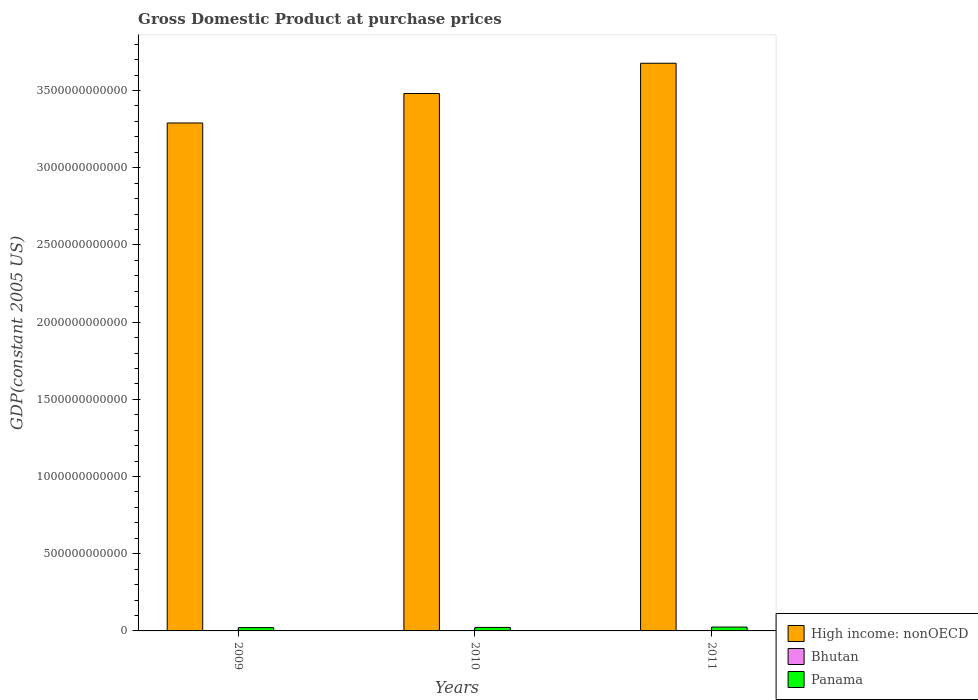Are the number of bars per tick equal to the number of legend labels?
Ensure brevity in your answer.  Yes. How many bars are there on the 1st tick from the left?
Give a very brief answer. 3. How many bars are there on the 1st tick from the right?
Your answer should be very brief. 3. What is the label of the 1st group of bars from the left?
Offer a terse response. 2009. In how many cases, is the number of bars for a given year not equal to the number of legend labels?
Offer a terse response. 0. What is the GDP at purchase prices in High income: nonOECD in 2011?
Your answer should be compact. 3.68e+12. Across all years, what is the maximum GDP at purchase prices in Panama?
Offer a terse response. 2.50e+1. Across all years, what is the minimum GDP at purchase prices in Bhutan?
Ensure brevity in your answer.  1.15e+09. In which year was the GDP at purchase prices in Panama maximum?
Provide a short and direct response. 2011. What is the total GDP at purchase prices in Bhutan in the graph?
Offer a terse response. 3.83e+09. What is the difference between the GDP at purchase prices in Panama in 2010 and that in 2011?
Your response must be concise. -2.43e+09. What is the difference between the GDP at purchase prices in Panama in 2011 and the GDP at purchase prices in High income: nonOECD in 2009?
Give a very brief answer. -3.26e+12. What is the average GDP at purchase prices in Panama per year?
Your answer should be very brief. 2.30e+1. In the year 2009, what is the difference between the GDP at purchase prices in Panama and GDP at purchase prices in Bhutan?
Provide a succinct answer. 2.02e+1. What is the ratio of the GDP at purchase prices in Panama in 2010 to that in 2011?
Your answer should be compact. 0.9. Is the GDP at purchase prices in High income: nonOECD in 2009 less than that in 2010?
Offer a very short reply. Yes. Is the difference between the GDP at purchase prices in Panama in 2009 and 2010 greater than the difference between the GDP at purchase prices in Bhutan in 2009 and 2010?
Offer a terse response. No. What is the difference between the highest and the second highest GDP at purchase prices in High income: nonOECD?
Make the answer very short. 1.96e+11. What is the difference between the highest and the lowest GDP at purchase prices in High income: nonOECD?
Your answer should be compact. 3.87e+11. In how many years, is the GDP at purchase prices in Bhutan greater than the average GDP at purchase prices in Bhutan taken over all years?
Your answer should be compact. 2. Is the sum of the GDP at purchase prices in Bhutan in 2009 and 2011 greater than the maximum GDP at purchase prices in High income: nonOECD across all years?
Ensure brevity in your answer.  No. What does the 1st bar from the left in 2009 represents?
Keep it short and to the point. High income: nonOECD. What does the 3rd bar from the right in 2011 represents?
Make the answer very short. High income: nonOECD. Is it the case that in every year, the sum of the GDP at purchase prices in Panama and GDP at purchase prices in High income: nonOECD is greater than the GDP at purchase prices in Bhutan?
Provide a short and direct response. Yes. How many bars are there?
Your answer should be very brief. 9. Are all the bars in the graph horizontal?
Give a very brief answer. No. What is the difference between two consecutive major ticks on the Y-axis?
Ensure brevity in your answer.  5.00e+11. Does the graph contain any zero values?
Keep it short and to the point. No. Does the graph contain grids?
Offer a very short reply. No. Where does the legend appear in the graph?
Your answer should be very brief. Bottom right. How are the legend labels stacked?
Give a very brief answer. Vertical. What is the title of the graph?
Your response must be concise. Gross Domestic Product at purchase prices. Does "French Polynesia" appear as one of the legend labels in the graph?
Offer a very short reply. No. What is the label or title of the X-axis?
Give a very brief answer. Years. What is the label or title of the Y-axis?
Your response must be concise. GDP(constant 2005 US). What is the GDP(constant 2005 US) in High income: nonOECD in 2009?
Make the answer very short. 3.29e+12. What is the GDP(constant 2005 US) of Bhutan in 2009?
Provide a short and direct response. 1.15e+09. What is the GDP(constant 2005 US) in Panama in 2009?
Make the answer very short. 2.14e+1. What is the GDP(constant 2005 US) of High income: nonOECD in 2010?
Keep it short and to the point. 3.48e+12. What is the GDP(constant 2005 US) in Bhutan in 2010?
Your answer should be compact. 1.29e+09. What is the GDP(constant 2005 US) of Panama in 2010?
Your response must be concise. 2.26e+1. What is the GDP(constant 2005 US) in High income: nonOECD in 2011?
Make the answer very short. 3.68e+12. What is the GDP(constant 2005 US) of Bhutan in 2011?
Offer a terse response. 1.39e+09. What is the GDP(constant 2005 US) of Panama in 2011?
Provide a succinct answer. 2.50e+1. Across all years, what is the maximum GDP(constant 2005 US) of High income: nonOECD?
Offer a very short reply. 3.68e+12. Across all years, what is the maximum GDP(constant 2005 US) in Bhutan?
Your answer should be compact. 1.39e+09. Across all years, what is the maximum GDP(constant 2005 US) in Panama?
Offer a very short reply. 2.50e+1. Across all years, what is the minimum GDP(constant 2005 US) of High income: nonOECD?
Offer a very short reply. 3.29e+12. Across all years, what is the minimum GDP(constant 2005 US) of Bhutan?
Make the answer very short. 1.15e+09. Across all years, what is the minimum GDP(constant 2005 US) of Panama?
Keep it short and to the point. 2.14e+1. What is the total GDP(constant 2005 US) in High income: nonOECD in the graph?
Your response must be concise. 1.04e+13. What is the total GDP(constant 2005 US) of Bhutan in the graph?
Your answer should be very brief. 3.83e+09. What is the total GDP(constant 2005 US) in Panama in the graph?
Your response must be concise. 6.90e+1. What is the difference between the GDP(constant 2005 US) in High income: nonOECD in 2009 and that in 2010?
Offer a very short reply. -1.91e+11. What is the difference between the GDP(constant 2005 US) of Bhutan in 2009 and that in 2010?
Provide a short and direct response. -1.35e+08. What is the difference between the GDP(constant 2005 US) of Panama in 2009 and that in 2010?
Keep it short and to the point. -1.25e+09. What is the difference between the GDP(constant 2005 US) in High income: nonOECD in 2009 and that in 2011?
Your response must be concise. -3.87e+11. What is the difference between the GDP(constant 2005 US) of Bhutan in 2009 and that in 2011?
Give a very brief answer. -2.37e+08. What is the difference between the GDP(constant 2005 US) of Panama in 2009 and that in 2011?
Provide a short and direct response. -3.68e+09. What is the difference between the GDP(constant 2005 US) in High income: nonOECD in 2010 and that in 2011?
Ensure brevity in your answer.  -1.96e+11. What is the difference between the GDP(constant 2005 US) of Bhutan in 2010 and that in 2011?
Your answer should be compact. -1.02e+08. What is the difference between the GDP(constant 2005 US) in Panama in 2010 and that in 2011?
Offer a terse response. -2.43e+09. What is the difference between the GDP(constant 2005 US) of High income: nonOECD in 2009 and the GDP(constant 2005 US) of Bhutan in 2010?
Offer a terse response. 3.29e+12. What is the difference between the GDP(constant 2005 US) of High income: nonOECD in 2009 and the GDP(constant 2005 US) of Panama in 2010?
Your response must be concise. 3.27e+12. What is the difference between the GDP(constant 2005 US) of Bhutan in 2009 and the GDP(constant 2005 US) of Panama in 2010?
Provide a short and direct response. -2.15e+1. What is the difference between the GDP(constant 2005 US) of High income: nonOECD in 2009 and the GDP(constant 2005 US) of Bhutan in 2011?
Offer a terse response. 3.29e+12. What is the difference between the GDP(constant 2005 US) of High income: nonOECD in 2009 and the GDP(constant 2005 US) of Panama in 2011?
Your answer should be very brief. 3.26e+12. What is the difference between the GDP(constant 2005 US) in Bhutan in 2009 and the GDP(constant 2005 US) in Panama in 2011?
Make the answer very short. -2.39e+1. What is the difference between the GDP(constant 2005 US) of High income: nonOECD in 2010 and the GDP(constant 2005 US) of Bhutan in 2011?
Make the answer very short. 3.48e+12. What is the difference between the GDP(constant 2005 US) of High income: nonOECD in 2010 and the GDP(constant 2005 US) of Panama in 2011?
Offer a terse response. 3.46e+12. What is the difference between the GDP(constant 2005 US) of Bhutan in 2010 and the GDP(constant 2005 US) of Panama in 2011?
Your answer should be very brief. -2.37e+1. What is the average GDP(constant 2005 US) in High income: nonOECD per year?
Your answer should be very brief. 3.48e+12. What is the average GDP(constant 2005 US) of Bhutan per year?
Your response must be concise. 1.28e+09. What is the average GDP(constant 2005 US) in Panama per year?
Your response must be concise. 2.30e+1. In the year 2009, what is the difference between the GDP(constant 2005 US) of High income: nonOECD and GDP(constant 2005 US) of Bhutan?
Keep it short and to the point. 3.29e+12. In the year 2009, what is the difference between the GDP(constant 2005 US) of High income: nonOECD and GDP(constant 2005 US) of Panama?
Your answer should be compact. 3.27e+12. In the year 2009, what is the difference between the GDP(constant 2005 US) of Bhutan and GDP(constant 2005 US) of Panama?
Your response must be concise. -2.02e+1. In the year 2010, what is the difference between the GDP(constant 2005 US) of High income: nonOECD and GDP(constant 2005 US) of Bhutan?
Your response must be concise. 3.48e+12. In the year 2010, what is the difference between the GDP(constant 2005 US) of High income: nonOECD and GDP(constant 2005 US) of Panama?
Provide a succinct answer. 3.46e+12. In the year 2010, what is the difference between the GDP(constant 2005 US) of Bhutan and GDP(constant 2005 US) of Panama?
Make the answer very short. -2.13e+1. In the year 2011, what is the difference between the GDP(constant 2005 US) in High income: nonOECD and GDP(constant 2005 US) in Bhutan?
Your response must be concise. 3.68e+12. In the year 2011, what is the difference between the GDP(constant 2005 US) in High income: nonOECD and GDP(constant 2005 US) in Panama?
Your answer should be compact. 3.65e+12. In the year 2011, what is the difference between the GDP(constant 2005 US) of Bhutan and GDP(constant 2005 US) of Panama?
Offer a very short reply. -2.36e+1. What is the ratio of the GDP(constant 2005 US) in High income: nonOECD in 2009 to that in 2010?
Give a very brief answer. 0.95. What is the ratio of the GDP(constant 2005 US) in Bhutan in 2009 to that in 2010?
Keep it short and to the point. 0.9. What is the ratio of the GDP(constant 2005 US) of Panama in 2009 to that in 2010?
Ensure brevity in your answer.  0.94. What is the ratio of the GDP(constant 2005 US) in High income: nonOECD in 2009 to that in 2011?
Offer a very short reply. 0.89. What is the ratio of the GDP(constant 2005 US) in Bhutan in 2009 to that in 2011?
Offer a very short reply. 0.83. What is the ratio of the GDP(constant 2005 US) in Panama in 2009 to that in 2011?
Provide a short and direct response. 0.85. What is the ratio of the GDP(constant 2005 US) in High income: nonOECD in 2010 to that in 2011?
Ensure brevity in your answer.  0.95. What is the ratio of the GDP(constant 2005 US) of Bhutan in 2010 to that in 2011?
Offer a very short reply. 0.93. What is the ratio of the GDP(constant 2005 US) in Panama in 2010 to that in 2011?
Provide a short and direct response. 0.9. What is the difference between the highest and the second highest GDP(constant 2005 US) in High income: nonOECD?
Keep it short and to the point. 1.96e+11. What is the difference between the highest and the second highest GDP(constant 2005 US) of Bhutan?
Your response must be concise. 1.02e+08. What is the difference between the highest and the second highest GDP(constant 2005 US) of Panama?
Make the answer very short. 2.43e+09. What is the difference between the highest and the lowest GDP(constant 2005 US) in High income: nonOECD?
Your answer should be very brief. 3.87e+11. What is the difference between the highest and the lowest GDP(constant 2005 US) in Bhutan?
Give a very brief answer. 2.37e+08. What is the difference between the highest and the lowest GDP(constant 2005 US) of Panama?
Ensure brevity in your answer.  3.68e+09. 